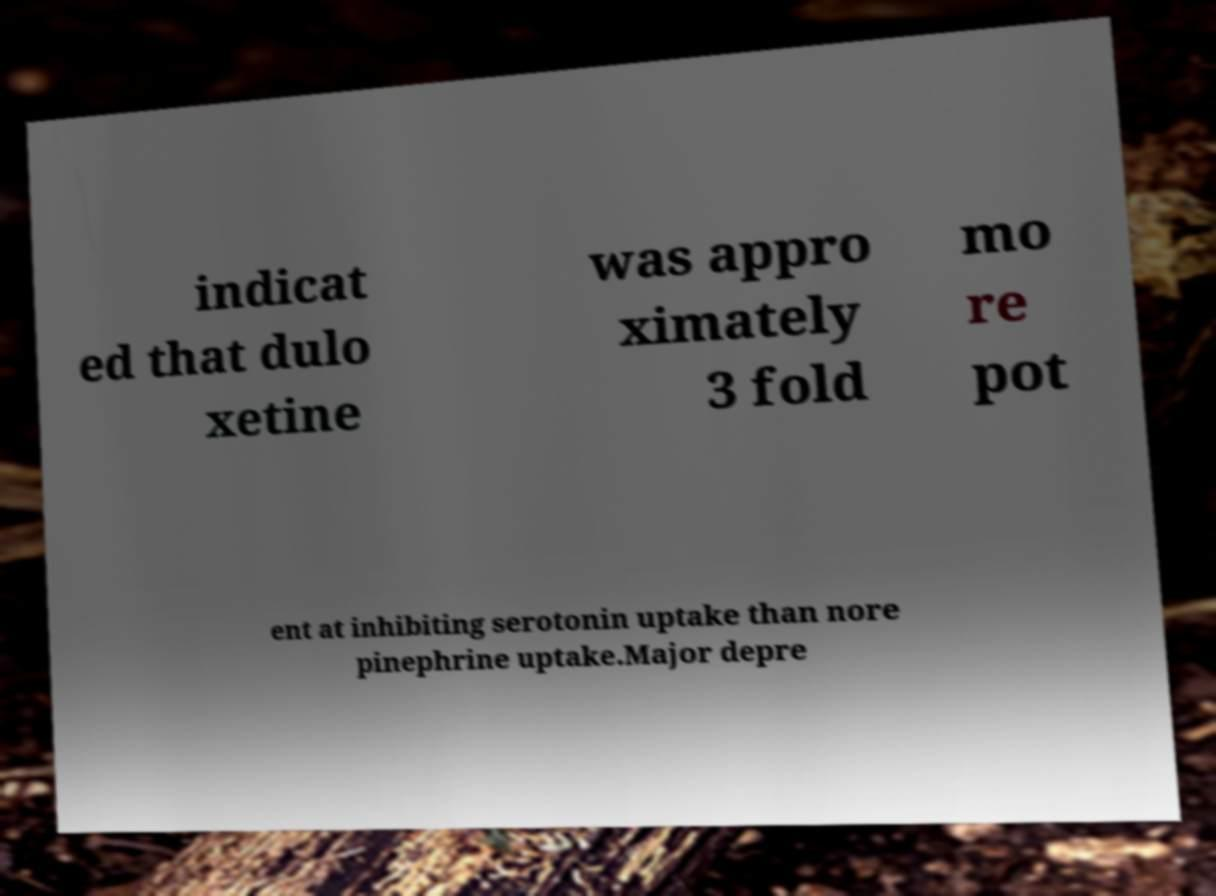Please read and relay the text visible in this image. What does it say? indicat ed that dulo xetine was appro ximately 3 fold mo re pot ent at inhibiting serotonin uptake than nore pinephrine uptake.Major depre 